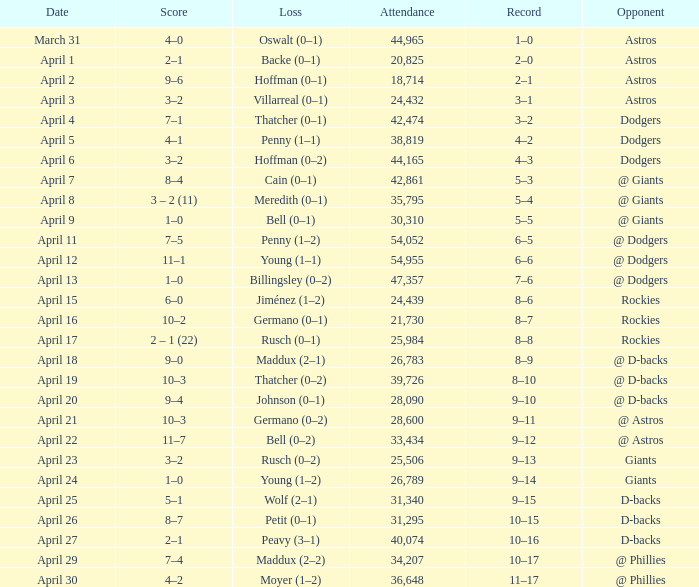What was the score on April 21? 10–3. 